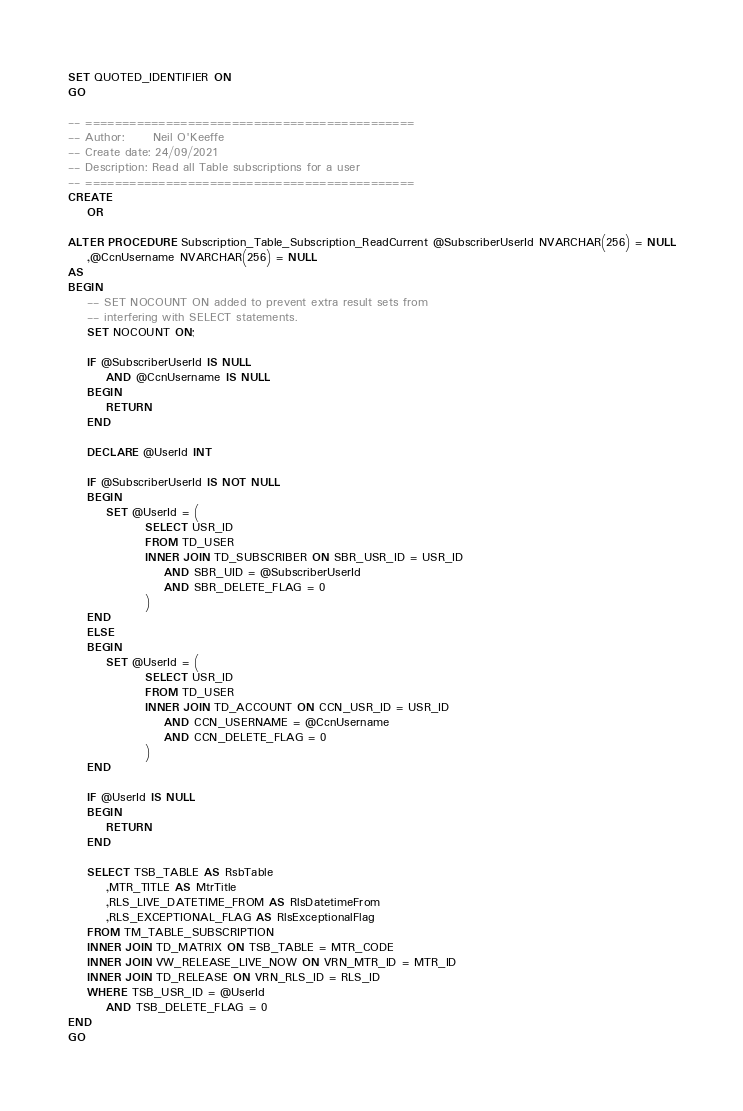<code> <loc_0><loc_0><loc_500><loc_500><_SQL_>
SET QUOTED_IDENTIFIER ON
GO

-- =============================================
-- Author:		Neil O'Keeffe
-- Create date: 24/09/2021
-- Description:	Read all Table subscriptions for a user
-- =============================================
CREATE
	OR

ALTER PROCEDURE Subscription_Table_Subscription_ReadCurrent @SubscriberUserId NVARCHAR(256) = NULL
	,@CcnUsername NVARCHAR(256) = NULL
AS
BEGIN
	-- SET NOCOUNT ON added to prevent extra result sets from
	-- interfering with SELECT statements.
	SET NOCOUNT ON;

	IF @SubscriberUserId IS NULL
		AND @CcnUsername IS NULL
	BEGIN
		RETURN
	END

	DECLARE @UserId INT

	IF @SubscriberUserId IS NOT NULL
	BEGIN
		SET @UserId = (
				SELECT USR_ID
				FROM TD_USER
				INNER JOIN TD_SUBSCRIBER ON SBR_USR_ID = USR_ID
					AND SBR_UID = @SubscriberUserId
					AND SBR_DELETE_FLAG = 0
				)
	END
	ELSE
	BEGIN
		SET @UserId = (
				SELECT USR_ID
				FROM TD_USER
				INNER JOIN TD_ACCOUNT ON CCN_USR_ID = USR_ID
					AND CCN_USERNAME = @CcnUsername
					AND CCN_DELETE_FLAG = 0
				)
	END

	IF @UserId IS NULL
	BEGIN
		RETURN
	END

	SELECT TSB_TABLE AS RsbTable
		,MTR_TITLE AS MtrTitle
		,RLS_LIVE_DATETIME_FROM AS RlsDatetimeFrom
		,RLS_EXCEPTIONAL_FLAG AS RlsExceptionalFlag
	FROM TM_TABLE_SUBSCRIPTION
	INNER JOIN TD_MATRIX ON TSB_TABLE = MTR_CODE
	INNER JOIN VW_RELEASE_LIVE_NOW ON VRN_MTR_ID = MTR_ID
	INNER JOIN TD_RELEASE ON VRN_RLS_ID = RLS_ID
	WHERE TSB_USR_ID = @UserId
		AND TSB_DELETE_FLAG = 0
END
GO


</code> 